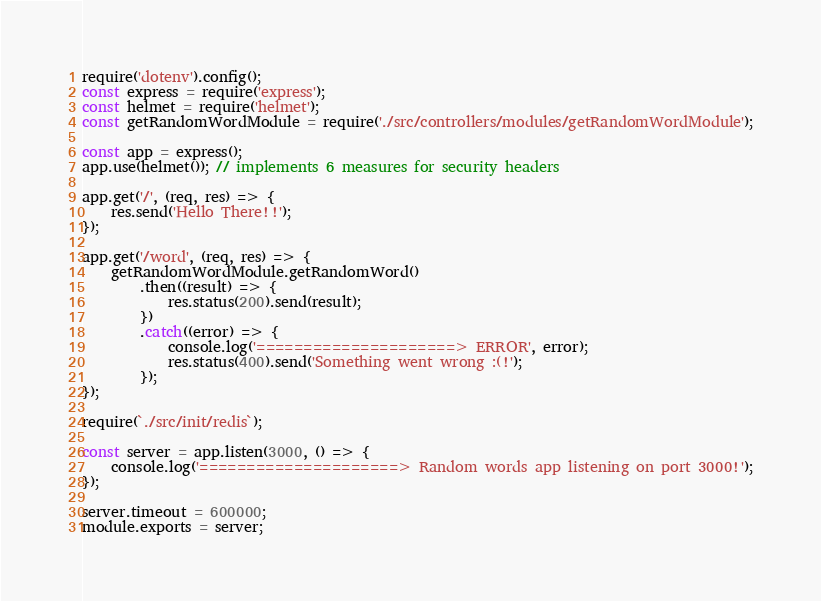<code> <loc_0><loc_0><loc_500><loc_500><_JavaScript_>require('dotenv').config();
const express = require('express');
const helmet = require('helmet');
const getRandomWordModule = require('./src/controllers/modules/getRandomWordModule');

const app = express();
app.use(helmet()); // implements 6 measures for security headers

app.get('/', (req, res) => {
    res.send('Hello There!!');
});

app.get('/word', (req, res) => {
    getRandomWordModule.getRandomWord()
        .then((result) => {
            res.status(200).send(result);
        })
        .catch((error) => {
            console.log('=====================> ERROR', error);
            res.status(400).send('Something went wrong :(!');
        });
});

require(`./src/init/redis`);

const server = app.listen(3000, () => {
    console.log('=====================> Random words app listening on port 3000!');
});

server.timeout = 600000;
module.exports = server;
</code> 